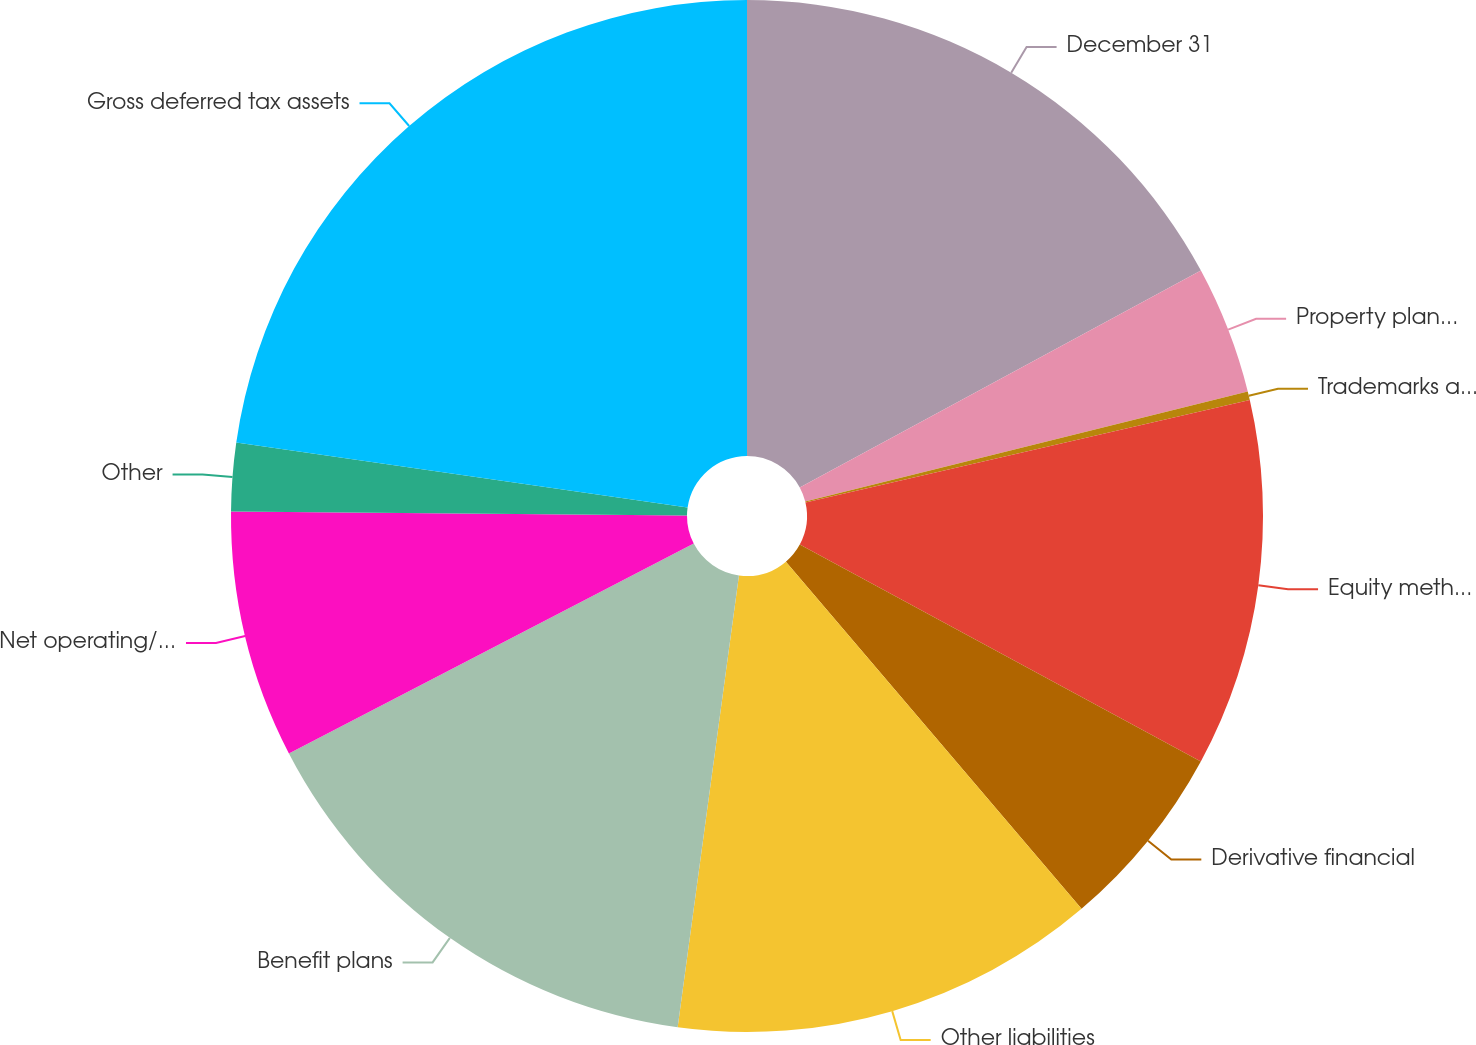Convert chart. <chart><loc_0><loc_0><loc_500><loc_500><pie_chart><fcel>December 31<fcel>Property plant and equipment<fcel>Trademarks and other<fcel>Equity method investments<fcel>Derivative financial<fcel>Other liabilities<fcel>Benefit plans<fcel>Net operating/capital loss<fcel>Other<fcel>Gross deferred tax assets<nl><fcel>17.11%<fcel>4.01%<fcel>0.27%<fcel>11.5%<fcel>5.88%<fcel>13.37%<fcel>15.24%<fcel>7.75%<fcel>2.14%<fcel>22.72%<nl></chart> 